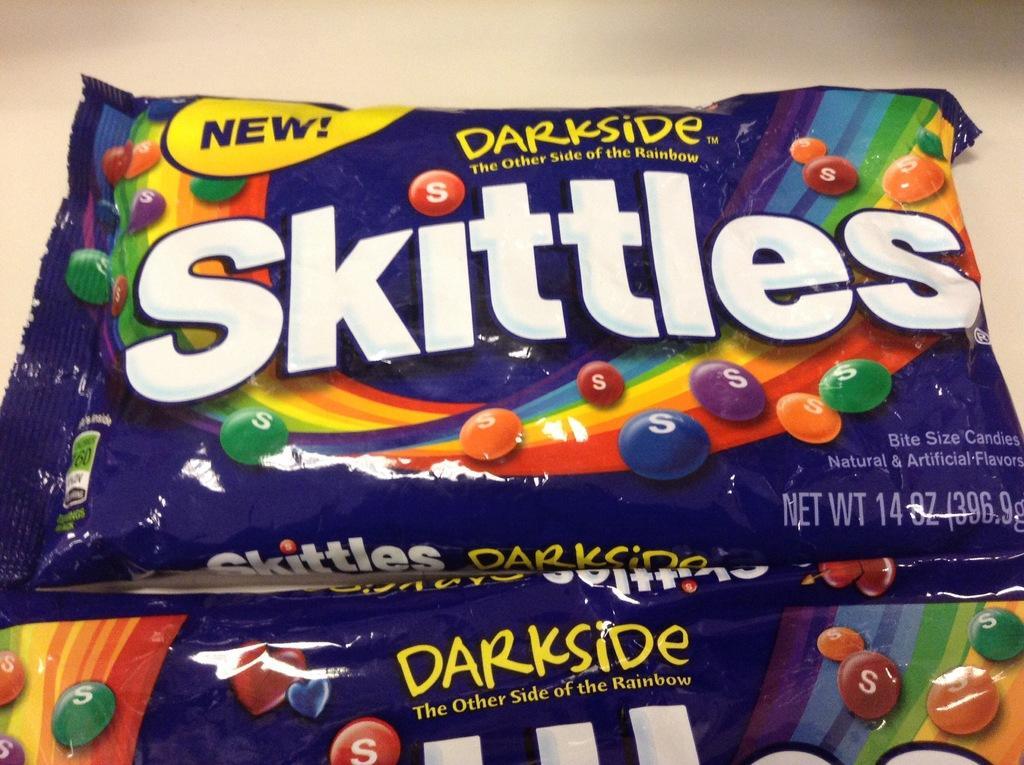Can you describe this image briefly? In this image there are packets of chocolate. On the packet ¨Skittles¨ is written. 